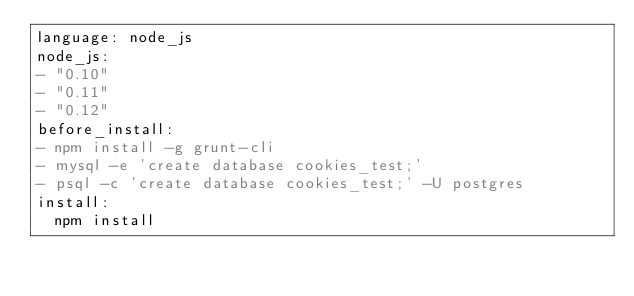Convert code to text. <code><loc_0><loc_0><loc_500><loc_500><_YAML_>language: node_js
node_js:
- "0.10"
- "0.11"
- "0.12"
before_install:
- npm install -g grunt-cli
- mysql -e 'create database cookies_test;'
- psql -c 'create database cookies_test;' -U postgres
install:
  npm install
</code> 